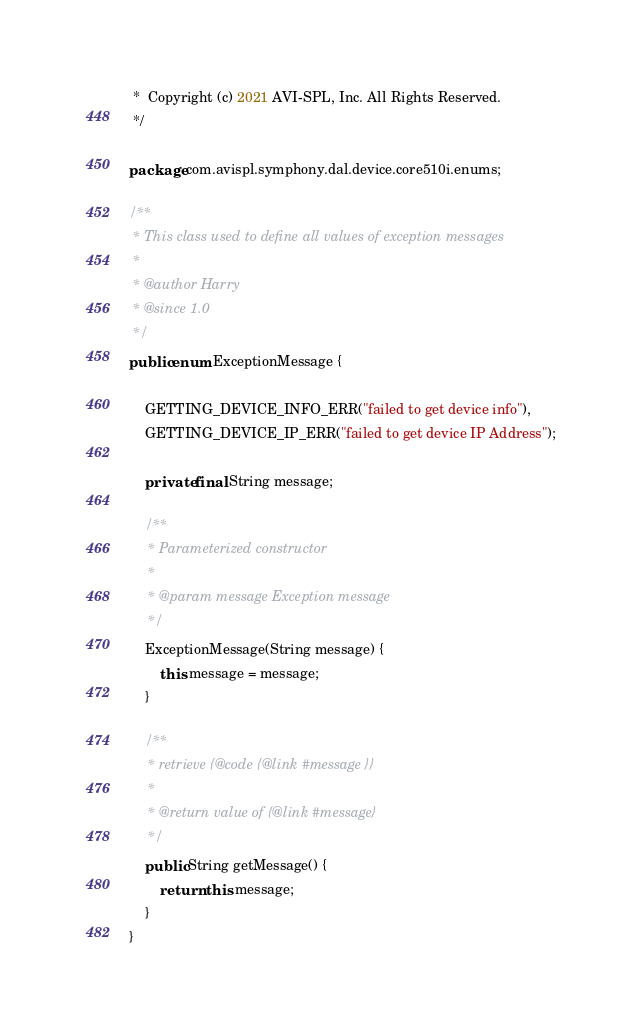<code> <loc_0><loc_0><loc_500><loc_500><_Java_> *  Copyright (c) 2021 AVI-SPL, Inc. All Rights Reserved.
 */

package com.avispl.symphony.dal.device.core510i.enums;

/**
 * This class used to define all values of exception messages
 *
 * @author Harry
 * @since 1.0
 */
public enum ExceptionMessage {

	GETTING_DEVICE_INFO_ERR("failed to get device info"),
	GETTING_DEVICE_IP_ERR("failed to get device IP Address");

	private final String message;

	/**
	 * Parameterized constructor
	 *
	 * @param message Exception message
	 */
	ExceptionMessage(String message) {
		this.message = message;
	}

	/**
	 * retrieve {@code {@link #message }}
	 *
	 * @return value of {@link #message}
	 */
	public String getMessage() {
		return this.message;
	}
}
</code> 